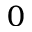<formula> <loc_0><loc_0><loc_500><loc_500>_ { 0 }</formula> 